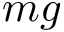Convert formula to latex. <formula><loc_0><loc_0><loc_500><loc_500>m g</formula> 